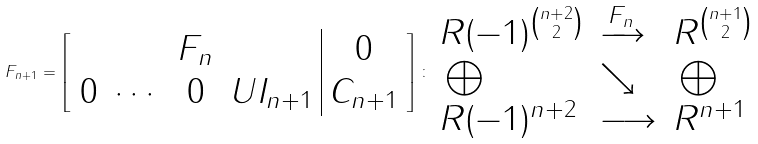Convert formula to latex. <formula><loc_0><loc_0><loc_500><loc_500>F _ { n + 1 } = \left [ \begin{array} { c c c c | c } & & F _ { n } & & 0 \\ 0 & \cdots & 0 & U I _ { n + 1 } & C _ { n + 1 } \end{array} \right ] \colon { \begin{array} { l l l } R ( - 1 ) ^ { \binom { n + 2 } { 2 } } & \xrightarrow { F _ { n } } & R ^ { \binom { n + 1 } { 2 } } \\ \, \bigoplus & \searrow & \, \bigoplus \\ R ( - 1 ) ^ { n + 2 } & \longrightarrow & R ^ { n + 1 } \end{array} }</formula> 